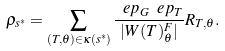<formula> <loc_0><loc_0><loc_500><loc_500>\rho _ { s ^ { * } } = \sum _ { ( T , \theta ) \in { \kappa } ( s ^ { * } ) } \frac { \ e p _ { G } \ e p _ { T } } { | W ( T ) ^ { F } _ { \theta } | } R _ { T , \theta } .</formula> 